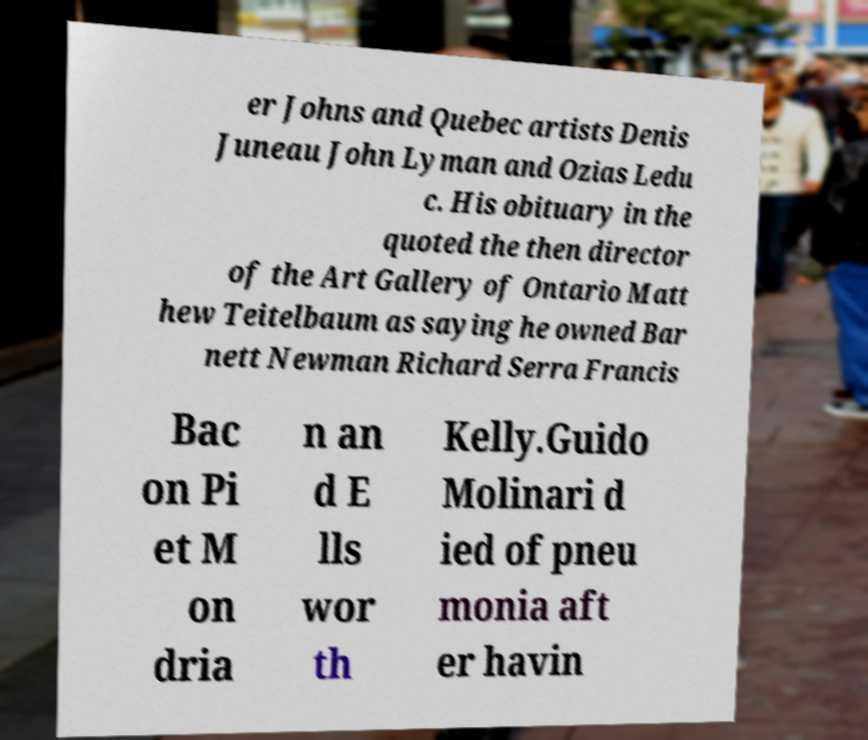Please identify and transcribe the text found in this image. er Johns and Quebec artists Denis Juneau John Lyman and Ozias Ledu c. His obituary in the quoted the then director of the Art Gallery of Ontario Matt hew Teitelbaum as saying he owned Bar nett Newman Richard Serra Francis Bac on Pi et M on dria n an d E lls wor th Kelly.Guido Molinari d ied of pneu monia aft er havin 